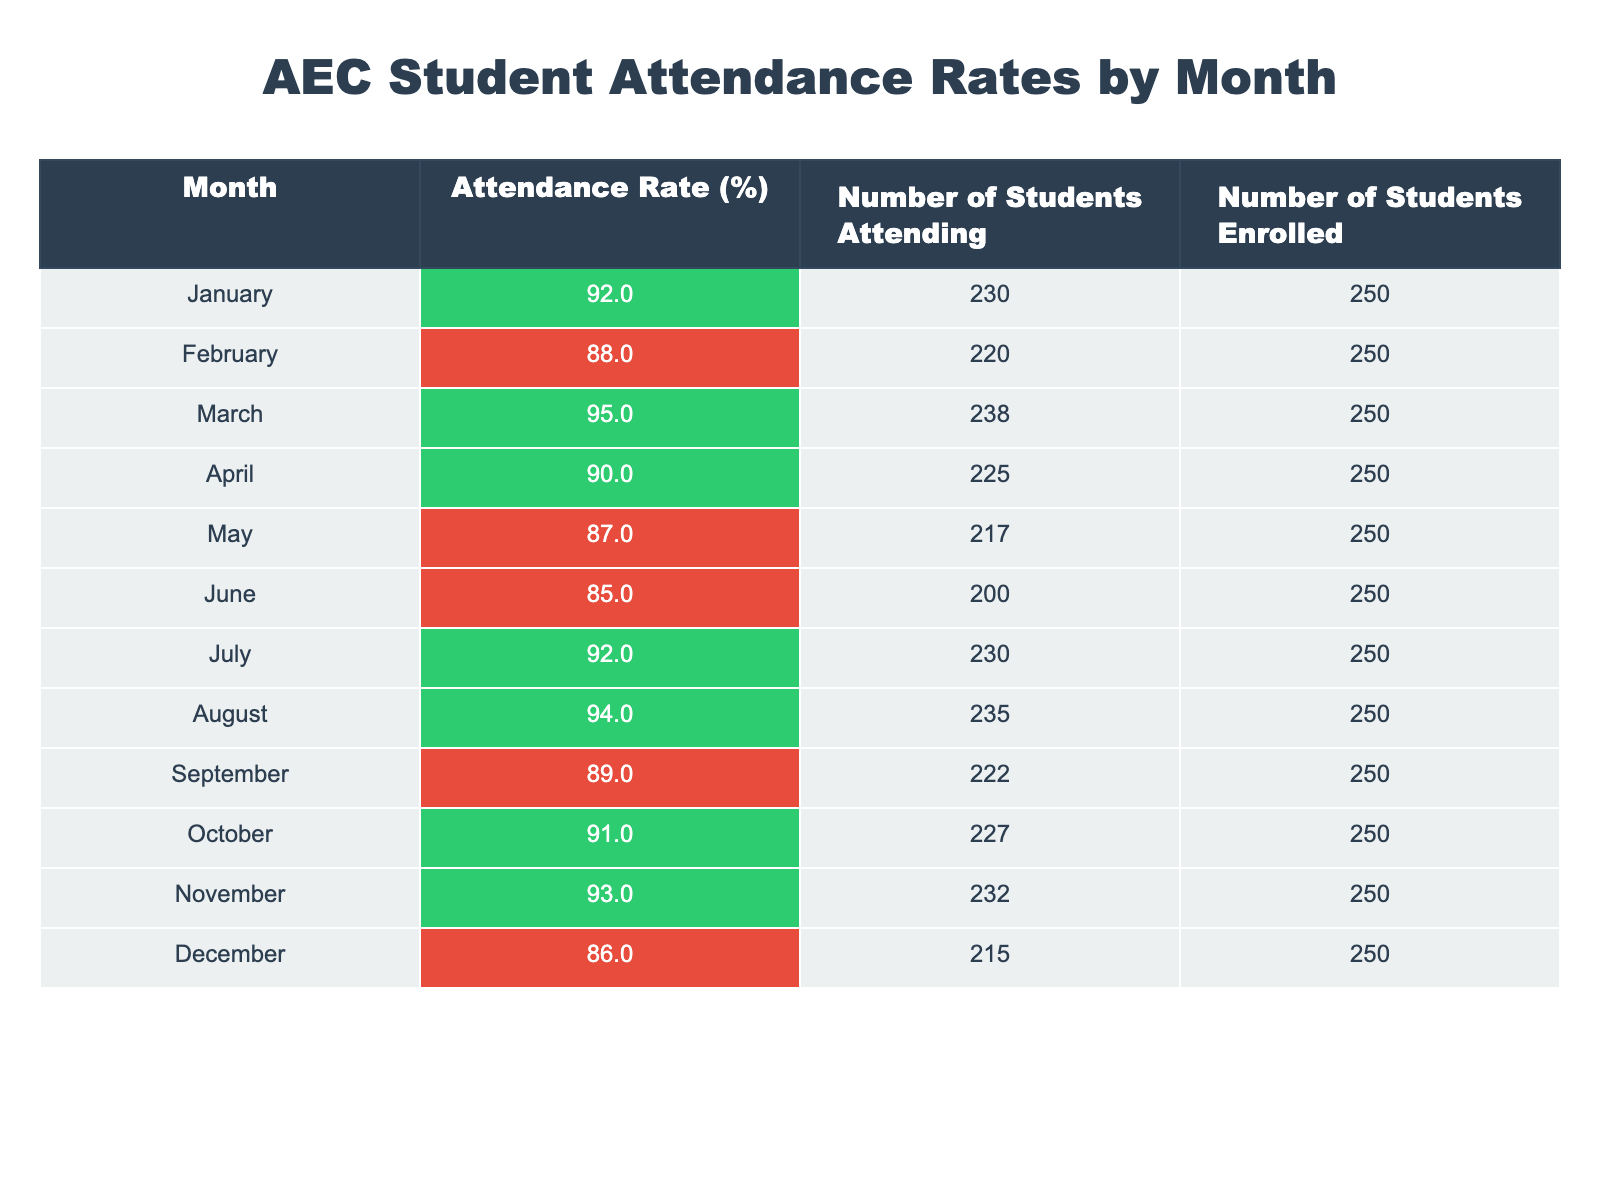What was the highest attendance rate recorded? Looking at the attendance rate values for each month, the highest rate is 95% in March.
Answer: 95% Which month had the lowest attendance rate? By examining the table, June has the lowest attendance rate at 85%.
Answer: June How many students attended in November? The table shows that 232 students attended in November.
Answer: 232 What is the average attendance rate for the year? To find the average, add all attendance rates: (92 + 88 + 95 + 90 + 87 + 85 + 92 + 94 + 89 + 91 + 93 + 86) = 1,075. Divide by 12 months to get 1,075 / 12 ≈ 89.58%.
Answer: 89.58% Did the attendance rate ever drop below 86%? The attendance rates for each month indicate that June and May dropped below 86%, with June at 85% and May at 87%.
Answer: Yes Which month showed an attendance increase compared to the previous month? Comparing consecutive months, March showed an increase from February (88% to 95%), April showed an increase from March (95% to 90%), and again, April to May showed a decrease instead. Thus, March to April is the only increase.
Answer: March to April How many students were enrolled each month? The table shows consistent enrollment of 250 students each month.
Answer: 250 What was the total number of students attending from January to December? To find the total, add the number of students attending each month: 230 + 220 + 238 + 225 + 217 + 200 + 230 + 235 + 222 + 227 + 232 + 215 = 2,749.
Answer: 2,749 Which months had an attendance rate of 90% or above? The months with an attendance rate of 90% or above are January, March, April, July, August, November, and October.
Answer: January, March, April, July, August, November, October How many more students attended in March than in May? March had 238 students attending, while May had 217. The difference is 238 - 217 = 21 students more in March.
Answer: 21 Was the attendance rate in August higher than in April? By comparing the rates, August had 94% and April had 90%, so the rate in August was indeed higher.
Answer: Yes 